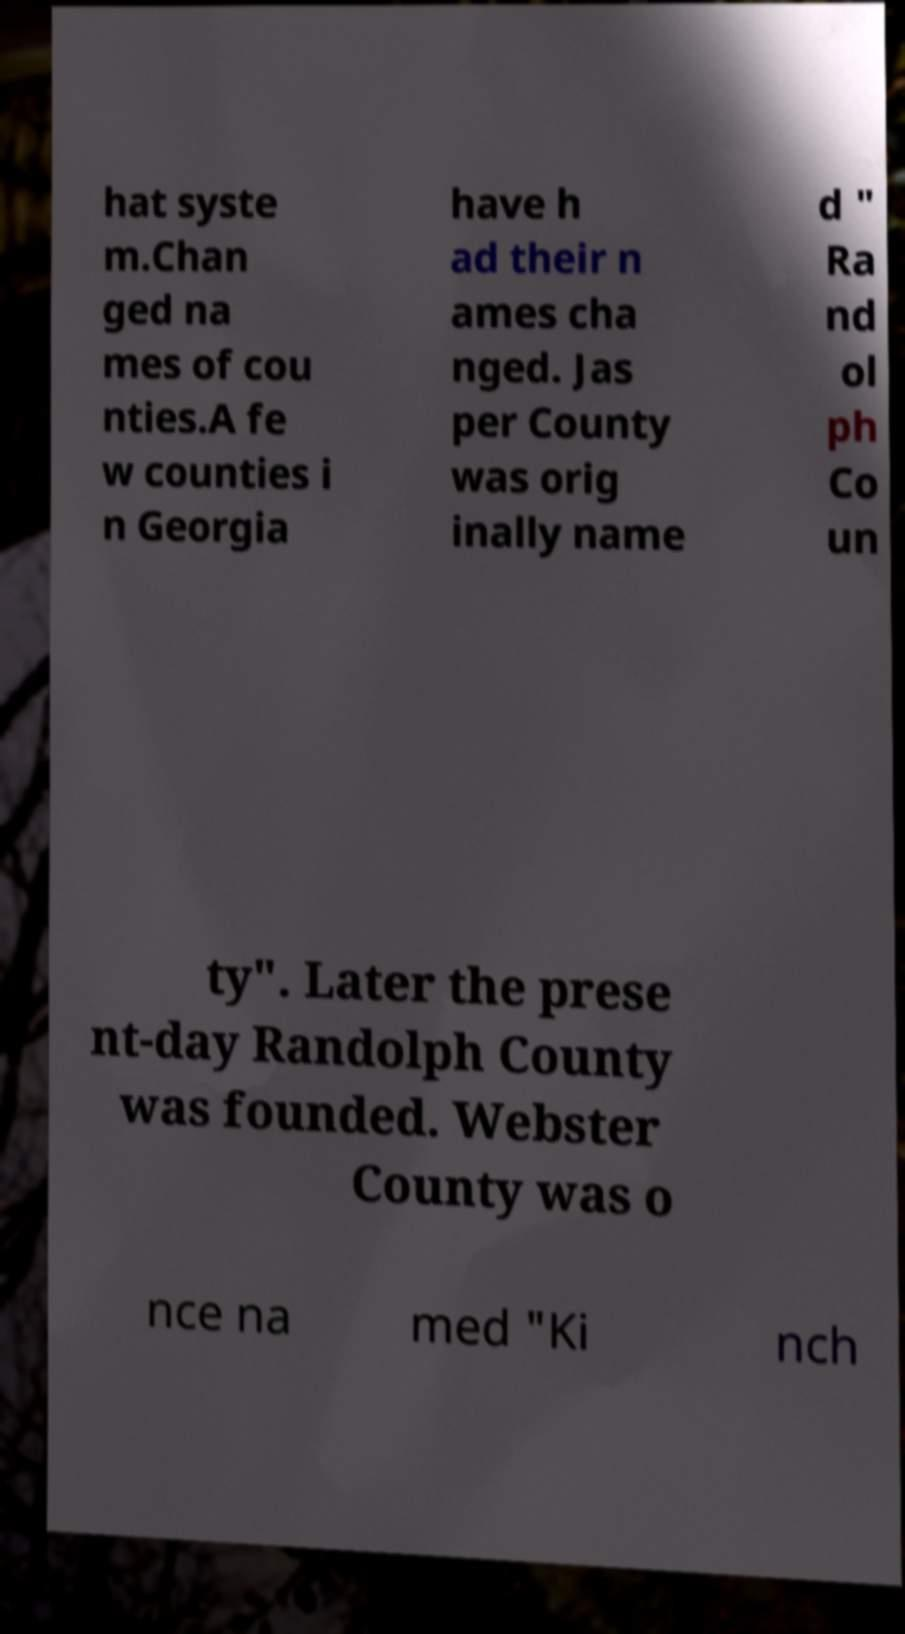Could you assist in decoding the text presented in this image and type it out clearly? hat syste m.Chan ged na mes of cou nties.A fe w counties i n Georgia have h ad their n ames cha nged. Jas per County was orig inally name d " Ra nd ol ph Co un ty". Later the prese nt-day Randolph County was founded. Webster County was o nce na med "Ki nch 